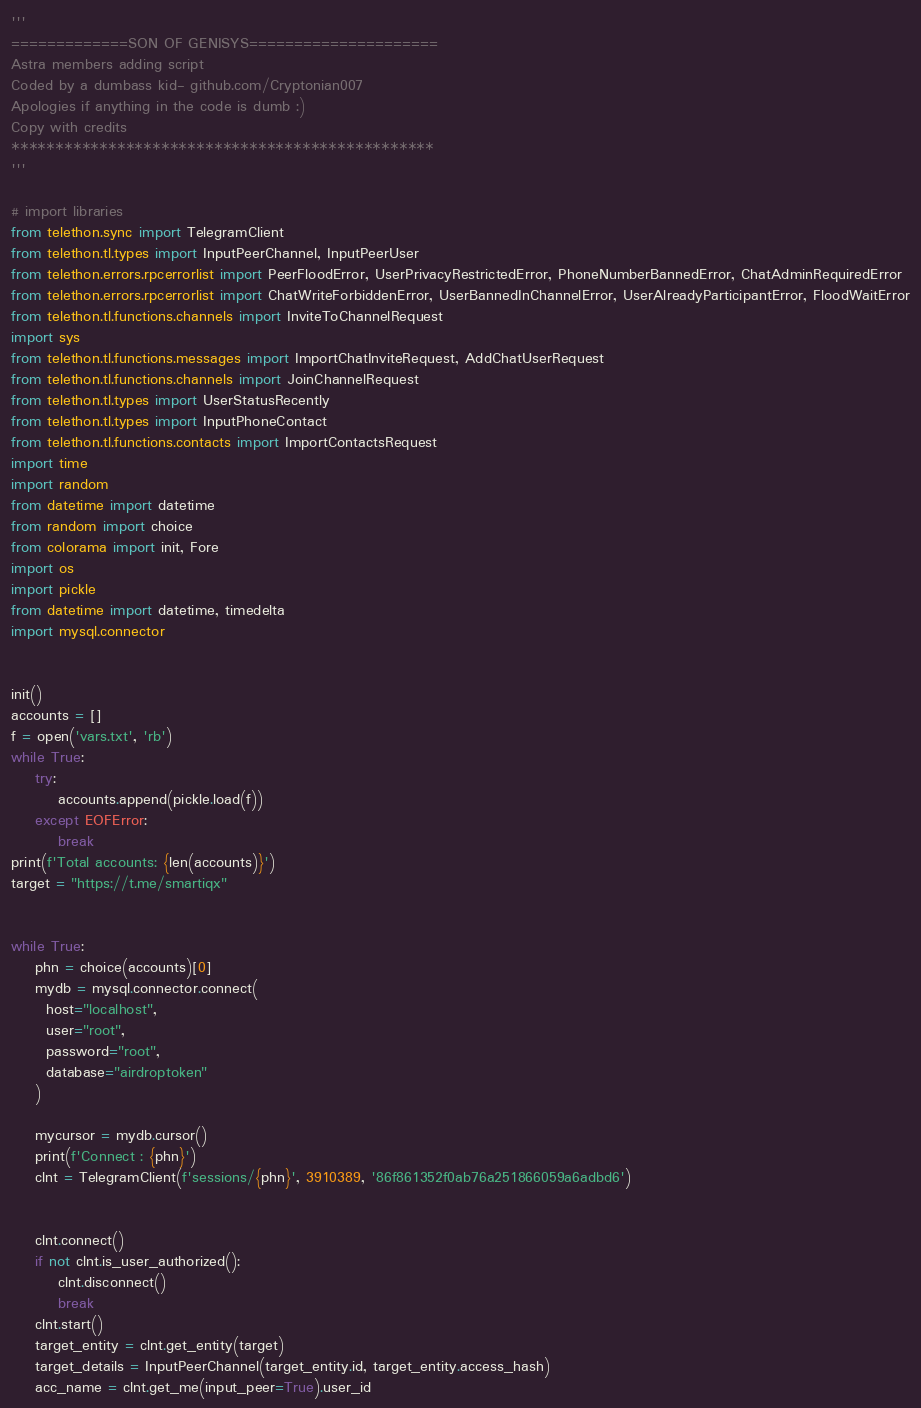Convert code to text. <code><loc_0><loc_0><loc_500><loc_500><_Python_>'''
=============SON OF GENISYS=====================
Astra members adding script
Coded by a dumbass kid- github.com/Cryptonian007
Apologies if anything in the code is dumb :)
Copy with credits
************************************************
'''

# import libraries
from telethon.sync import TelegramClient
from telethon.tl.types import InputPeerChannel, InputPeerUser
from telethon.errors.rpcerrorlist import PeerFloodError, UserPrivacyRestrictedError, PhoneNumberBannedError, ChatAdminRequiredError
from telethon.errors.rpcerrorlist import ChatWriteForbiddenError, UserBannedInChannelError, UserAlreadyParticipantError, FloodWaitError
from telethon.tl.functions.channels import InviteToChannelRequest
import sys
from telethon.tl.functions.messages import ImportChatInviteRequest, AddChatUserRequest
from telethon.tl.functions.channels import JoinChannelRequest
from telethon.tl.types import UserStatusRecently
from telethon.tl.types import InputPhoneContact
from telethon.tl.functions.contacts import ImportContactsRequest
import time
import random
from datetime import datetime
from random import choice
from colorama import init, Fore
import os
import pickle
from datetime import datetime, timedelta
import mysql.connector


init()
accounts = []
f = open('vars.txt', 'rb')
while True:
    try:
        accounts.append(pickle.load(f))
    except EOFError:
        break
print(f'Total accounts: {len(accounts)}')
target = "https://t.me/smartiqx"


while True:
	phn = choice(accounts)[0]
	mydb = mysql.connector.connect(
	  host="localhost",
	  user="root",
	  password="root",
	  database="airdroptoken"
	)

	mycursor = mydb.cursor()
	print(f'Connect : {phn}')
	clnt = TelegramClient(f'sessions/{phn}', 3910389, '86f861352f0ab76a251866059a6adbd6')
	
	
	clnt.connect()
	if not clnt.is_user_authorized():
		clnt.disconnect()
		break
	clnt.start()
	target_entity = clnt.get_entity(target)
	target_details = InputPeerChannel(target_entity.id, target_entity.access_hash)
	acc_name = clnt.get_me(input_peer=True).user_id
</code> 